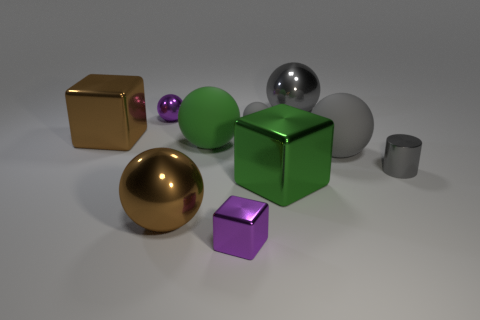Is the color of the tiny metal ball the same as the tiny shiny block?
Ensure brevity in your answer.  Yes. Does the big object that is behind the tiny purple ball have the same color as the small metallic cylinder?
Offer a terse response. Yes. There is a small matte object that is the same color as the small cylinder; what is its shape?
Your answer should be compact. Sphere. There is a tiny ball on the right side of the green ball; does it have the same color as the shiny ball that is right of the brown ball?
Give a very brief answer. Yes. Are there any big green objects behind the green rubber thing?
Offer a very short reply. No. There is a gray metallic object that is behind the gray metal object right of the big gray ball behind the large green sphere; what is its size?
Your answer should be very brief. Large. There is a tiny gray object behind the metallic cylinder; does it have the same shape as the large green thing that is to the left of the small purple shiny block?
Give a very brief answer. Yes. There is a purple metal thing that is the same shape as the large gray metallic thing; what size is it?
Your answer should be very brief. Small. How many gray cylinders are made of the same material as the large brown sphere?
Ensure brevity in your answer.  1. What material is the big green ball?
Your answer should be compact. Rubber. 